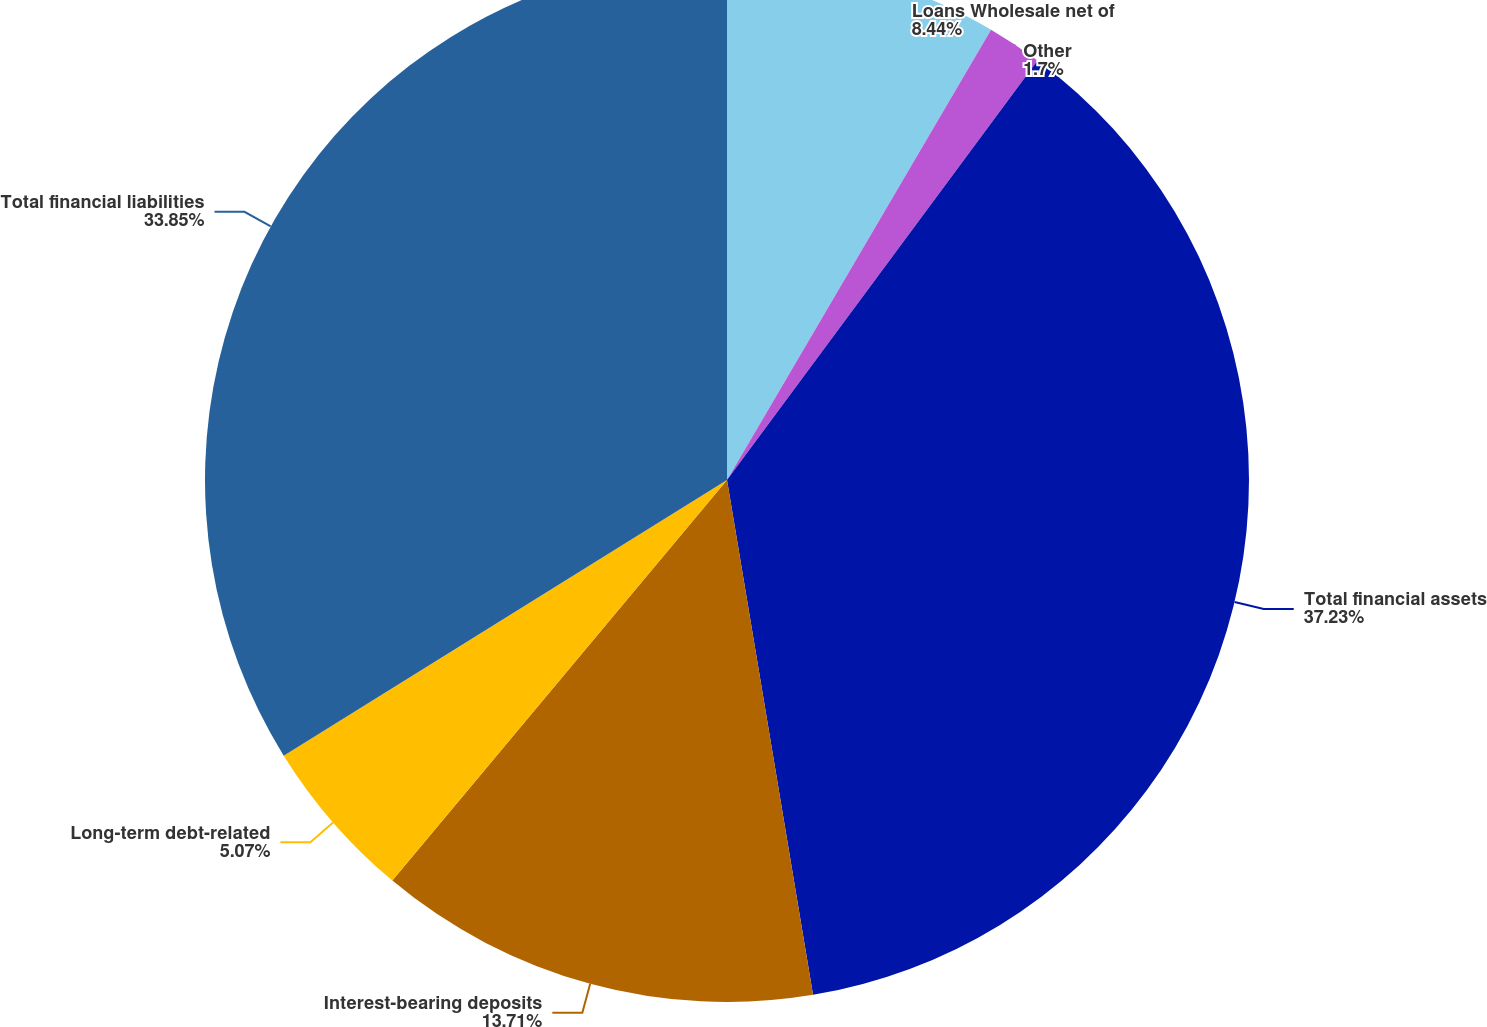Convert chart to OTSL. <chart><loc_0><loc_0><loc_500><loc_500><pie_chart><fcel>Loans Wholesale net of<fcel>Other<fcel>Total financial assets<fcel>Interest-bearing deposits<fcel>Long-term debt-related<fcel>Total financial liabilities<nl><fcel>8.44%<fcel>1.7%<fcel>37.22%<fcel>13.71%<fcel>5.07%<fcel>33.85%<nl></chart> 